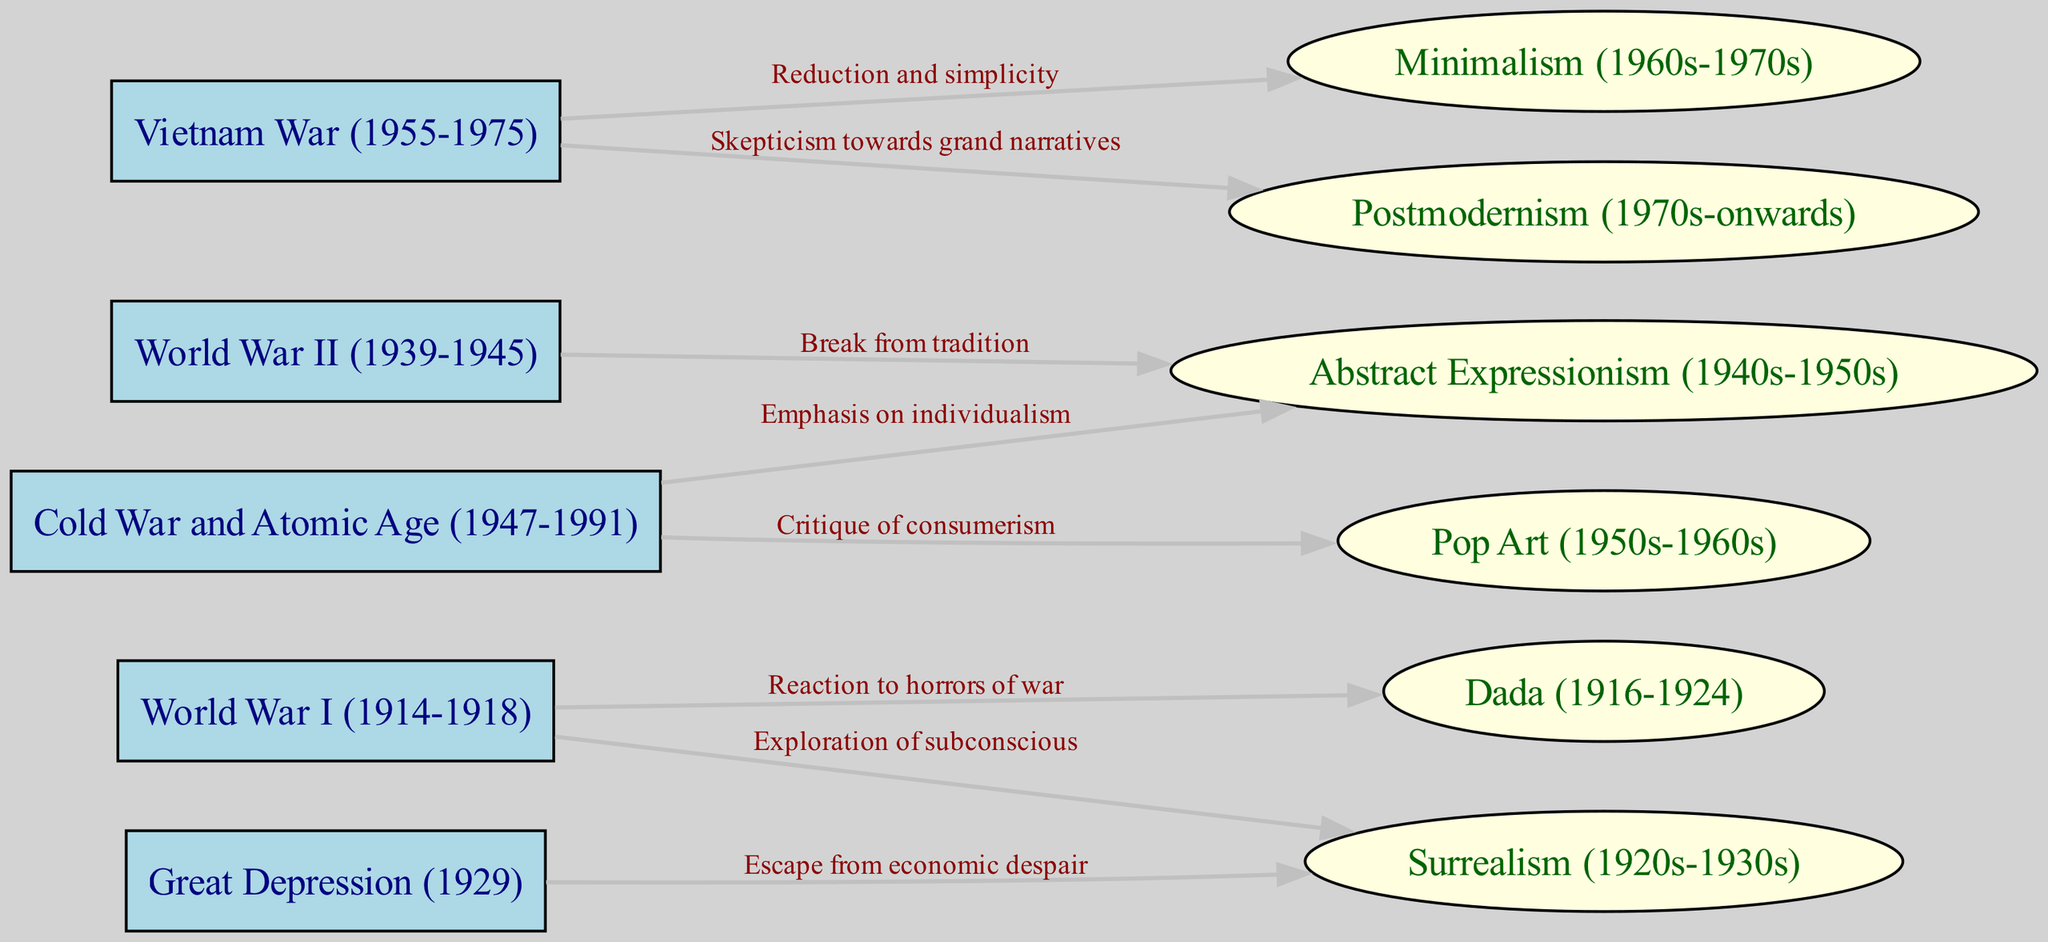What event is linked to Dada? The diagram shows an edge from "World War I" to "Dada," labeled "Reaction to horrors of war." This indicates that Dada emerged as a response to the experiences of World War I.
Answer: World War I How many art movements are affected by the Great Depression? In the diagram, there are two art movements connected to the "Great Depression" node: "Surrealism" and "Pop Art." Therefore, we count these connections to find the total.
Answer: 2 What are the two influences on Surrealism? The diagram indicates two edges leading from distinct nodes to "Surrealism." One comes from "World War I" highlighting the exploration of subconscious, and the other from "Great Depression," emphasizing an escape from economic despair. This leads to identifying the two historical events.
Answer: World War I and Great Depression What does the Vietnam War influence? According to the diagram, the "Vietnam War" node has two outgoing edges connecting to "Minimalism" and "Postmodernism," respectively, indicating it influenced both of these art movements.
Answer: Minimalism and Postmodernism Which artistic movement is associated with the Cold War? The diagram cites "Abstract Expressionism" and "Pop Art" as movements influenced by the "Cold War." These connections suggest how the political climate during that period affected artistic expression.
Answer: Abstract Expressionism and Pop Art What major event leads to the emergence of Abstract Expressionism? The diagram illustrates two edges leading to "Abstract Expressionism": one from "World War II," emphasizing a break from tradition, and another from the "Cold War," focusing on individualism. Hence, we track back to see these influencing events.
Answer: World War II and Cold War Which movement critiques consumerism? In the visual representation, the edge from "Cold War" to "Pop Art" features the label "Critique of consumerism." This shows a specific focus of Pop Art that emerged during the Cold War era.
Answer: Pop Art How many nodes represent wars in the diagram? The diagram features four nodes with war references: "World War I," "World War II," "Great Depression" (considered a significant historical impact), and "Vietnam War." Counting these gives us the total number of war nodes present.
Answer: 4 